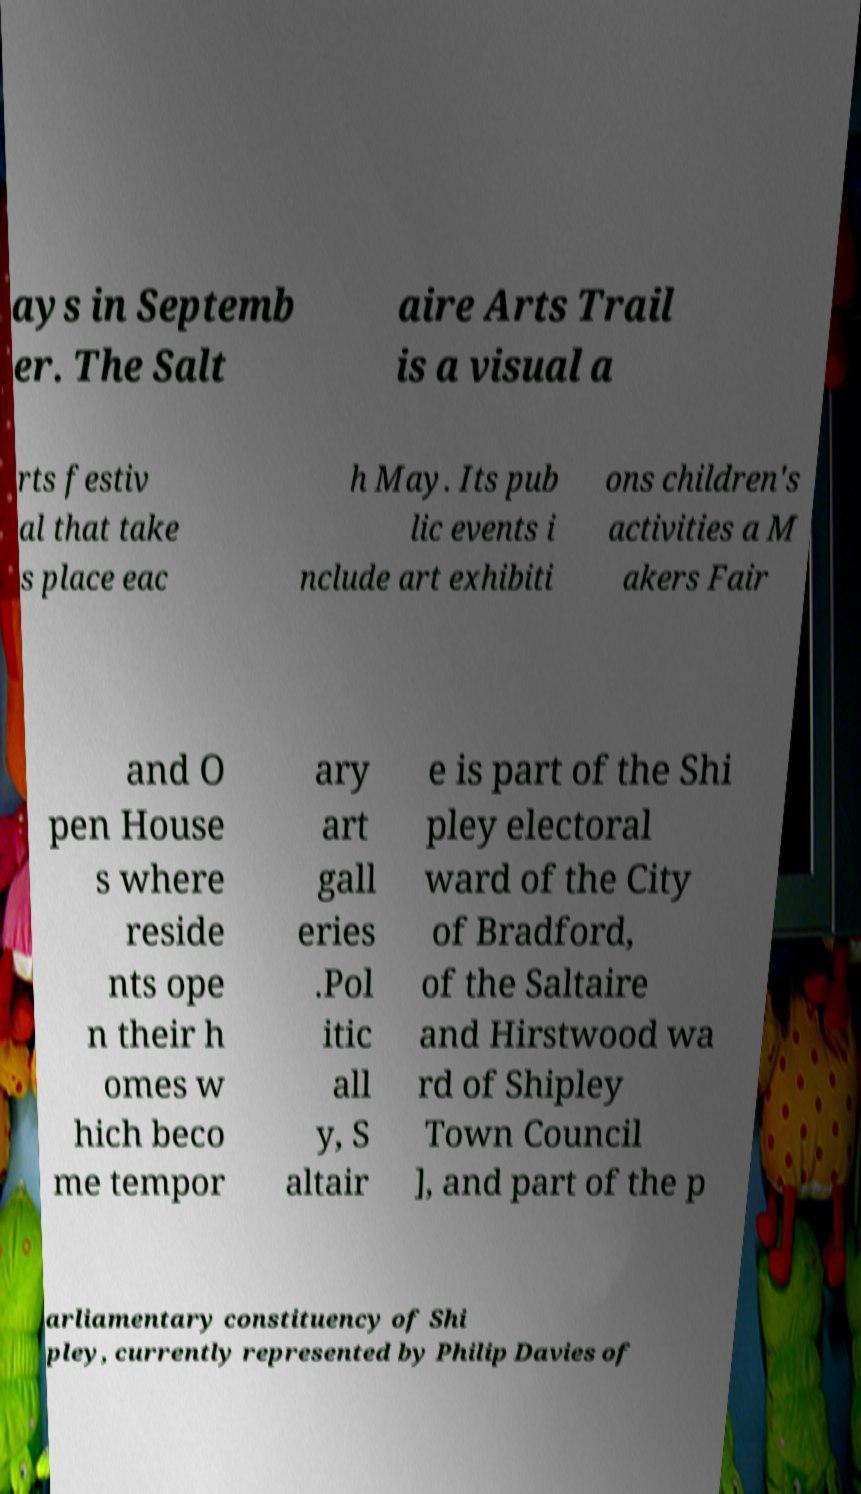I need the written content from this picture converted into text. Can you do that? ays in Septemb er. The Salt aire Arts Trail is a visual a rts festiv al that take s place eac h May. Its pub lic events i nclude art exhibiti ons children's activities a M akers Fair and O pen House s where reside nts ope n their h omes w hich beco me tempor ary art gall eries .Pol itic all y, S altair e is part of the Shi pley electoral ward of the City of Bradford, of the Saltaire and Hirstwood wa rd of Shipley Town Council ], and part of the p arliamentary constituency of Shi pley, currently represented by Philip Davies of 